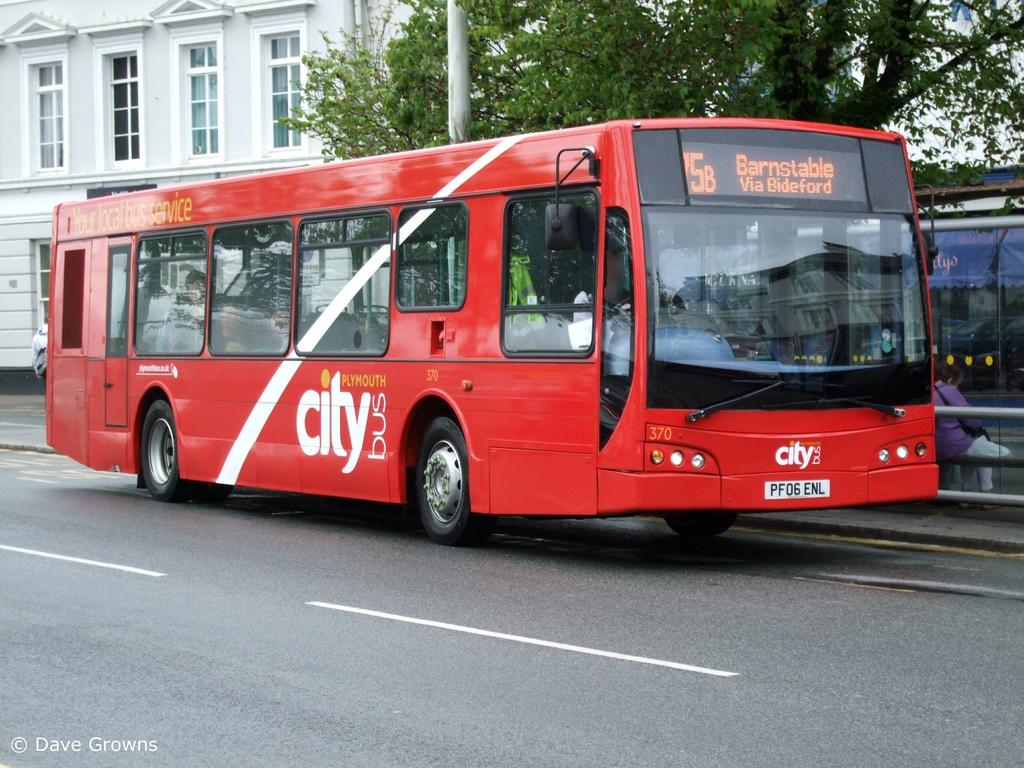What type of bus is this?
Give a very brief answer. City. 